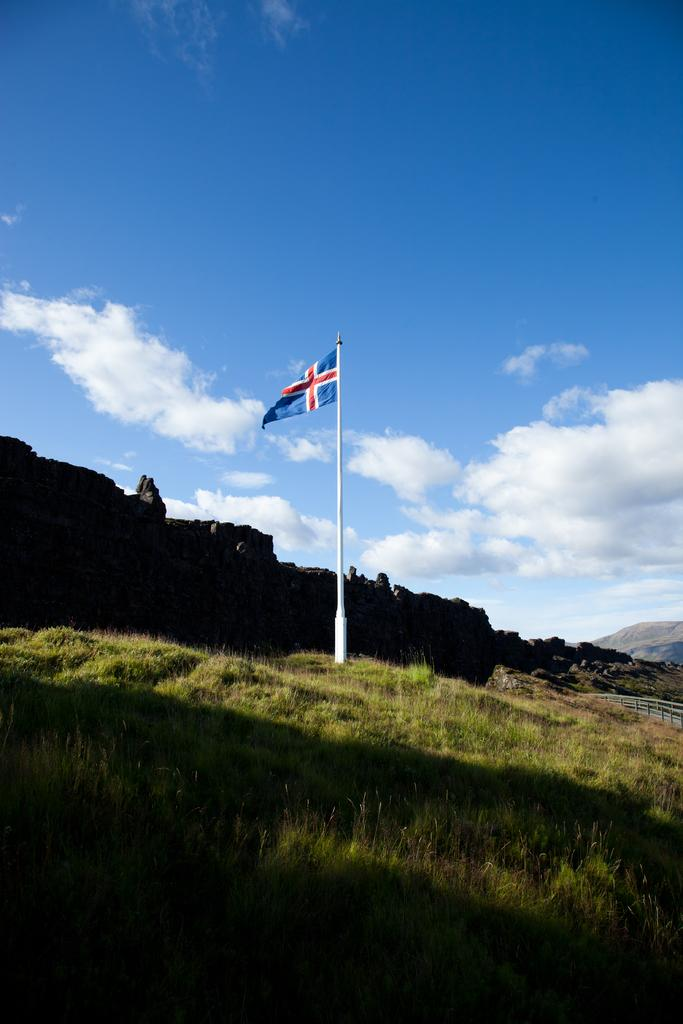What type of vegetation is present in the image? There is grass in the image. What is located in the middle of the image? There is a flag in the middle of the image. What can be seen in the background of the image? There is a fence, hills, and clouds visible in the background of the image. Where is the hospital located in the image? There is no hospital present in the image. What type of food is being served in the lunchroom in the image? There is no lunchroom present in the image. 